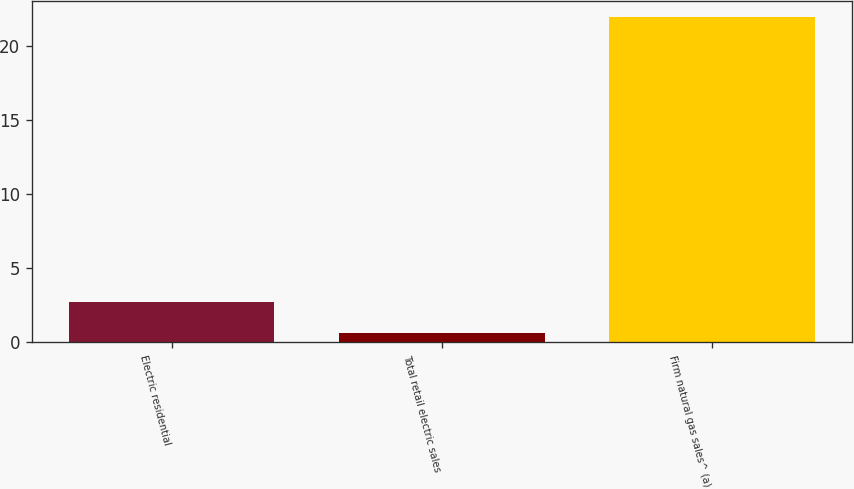Convert chart to OTSL. <chart><loc_0><loc_0><loc_500><loc_500><bar_chart><fcel>Electric residential<fcel>Total retail electric sales<fcel>Firm natural gas sales^ (a)<nl><fcel>2.73<fcel>0.6<fcel>21.9<nl></chart> 